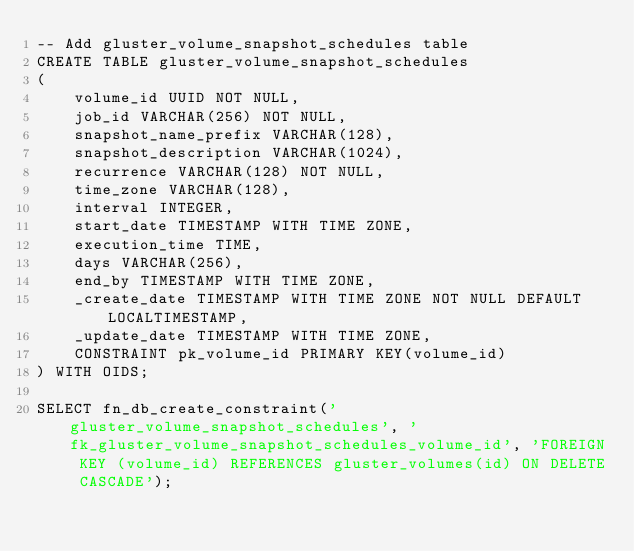<code> <loc_0><loc_0><loc_500><loc_500><_SQL_>-- Add gluster_volume_snapshot_schedules table
CREATE TABLE gluster_volume_snapshot_schedules
(
    volume_id UUID NOT NULL,
    job_id VARCHAR(256) NOT NULL,
    snapshot_name_prefix VARCHAR(128),
    snapshot_description VARCHAR(1024),
    recurrence VARCHAR(128) NOT NULL,
    time_zone VARCHAR(128),
    interval INTEGER,
    start_date TIMESTAMP WITH TIME ZONE,
    execution_time TIME,
    days VARCHAR(256),
    end_by TIMESTAMP WITH TIME ZONE,
    _create_date TIMESTAMP WITH TIME ZONE NOT NULL DEFAULT LOCALTIMESTAMP,
    _update_date TIMESTAMP WITH TIME ZONE,
    CONSTRAINT pk_volume_id PRIMARY KEY(volume_id)
) WITH OIDS;

SELECT fn_db_create_constraint('gluster_volume_snapshot_schedules', 'fk_gluster_volume_snapshot_schedules_volume_id', 'FOREIGN KEY (volume_id) REFERENCES gluster_volumes(id) ON DELETE CASCADE');

</code> 